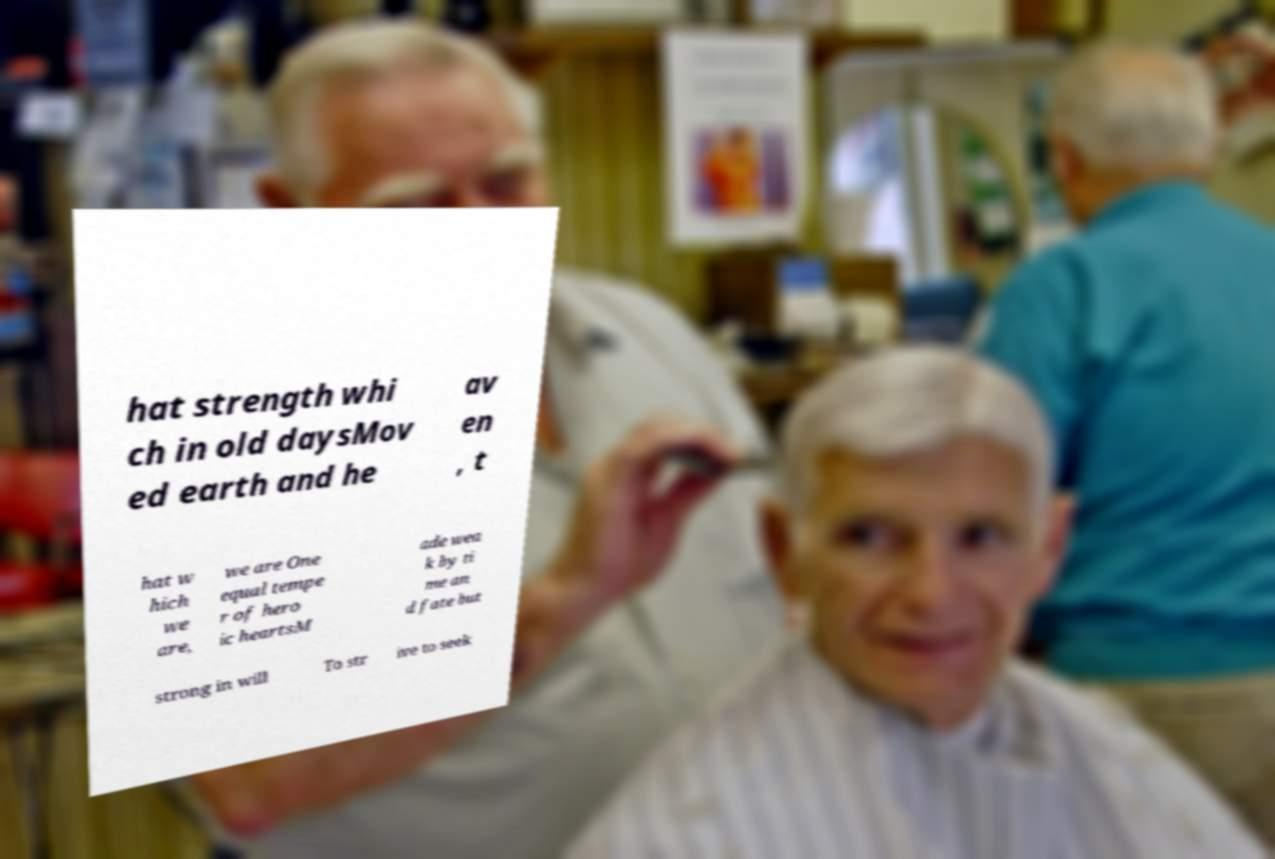Could you assist in decoding the text presented in this image and type it out clearly? hat strength whi ch in old daysMov ed earth and he av en , t hat w hich we are, we are One equal tempe r of hero ic heartsM ade wea k by ti me an d fate but strong in will To str ive to seek 